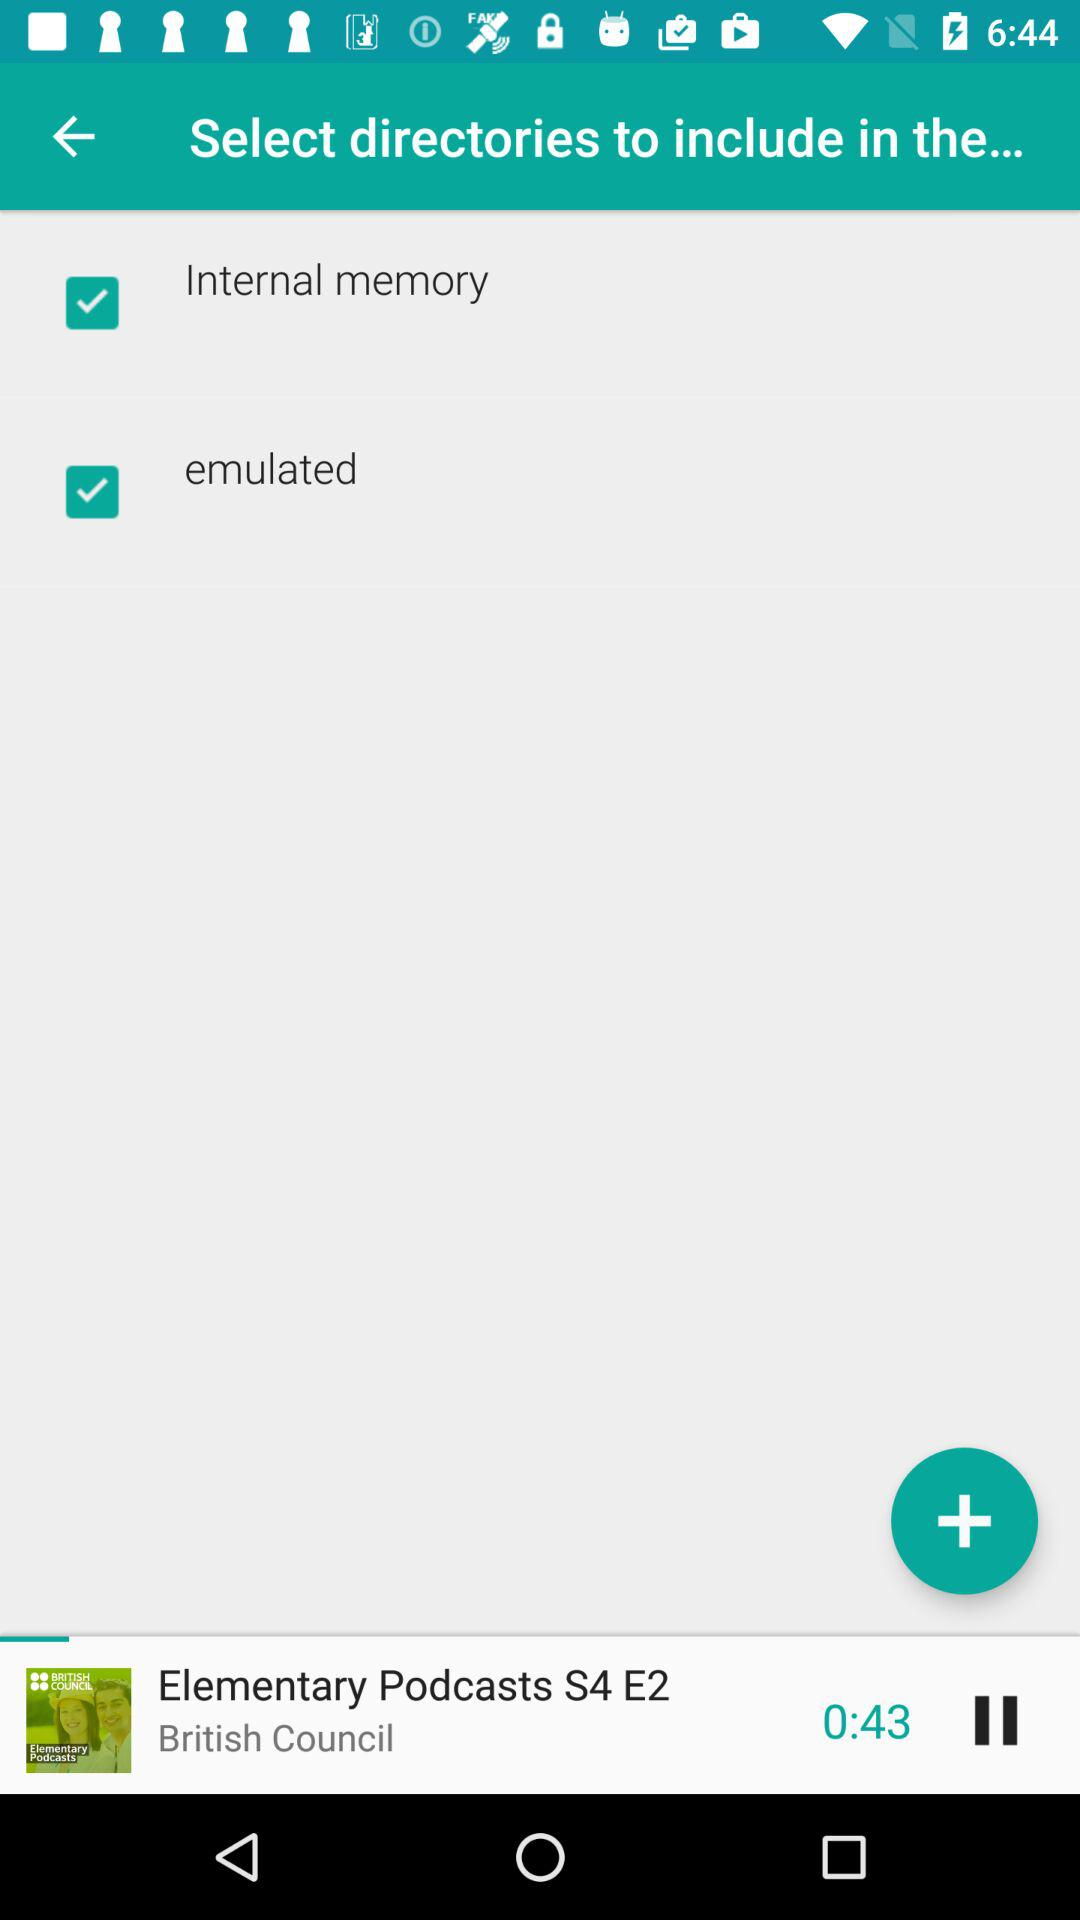What is the name of the audio that is playing? The name of the audio that is playing is "Elementary Podcasts S4 E2". 